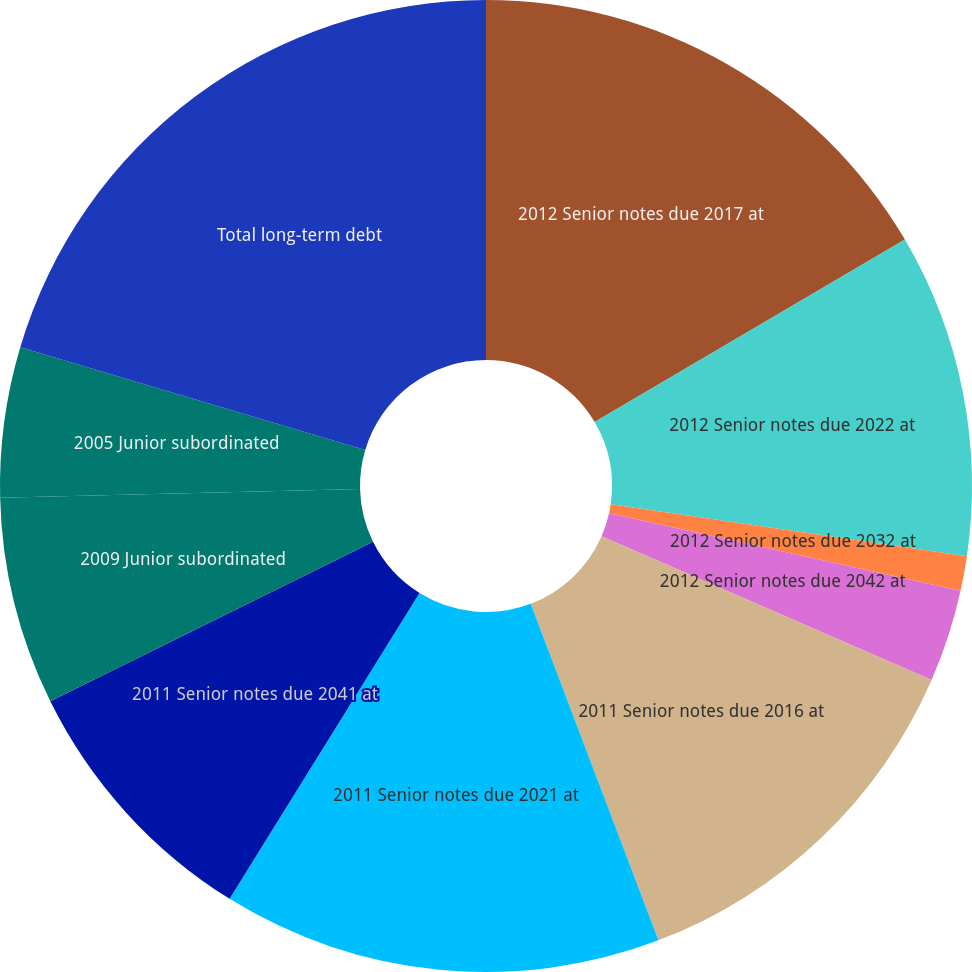Convert chart to OTSL. <chart><loc_0><loc_0><loc_500><loc_500><pie_chart><fcel>2012 Senior notes due 2017 at<fcel>2012 Senior notes due 2022 at<fcel>2012 Senior notes due 2032 at<fcel>2012 Senior notes due 2042 at<fcel>2011 Senior notes due 2016 at<fcel>2011 Senior notes due 2021 at<fcel>2011 Senior notes due 2041 at<fcel>2009 Junior subordinated<fcel>2005 Junior subordinated<fcel>Total long-term debt<nl><fcel>16.54%<fcel>10.77%<fcel>1.15%<fcel>3.08%<fcel>12.69%<fcel>14.62%<fcel>8.85%<fcel>6.92%<fcel>5.0%<fcel>20.39%<nl></chart> 